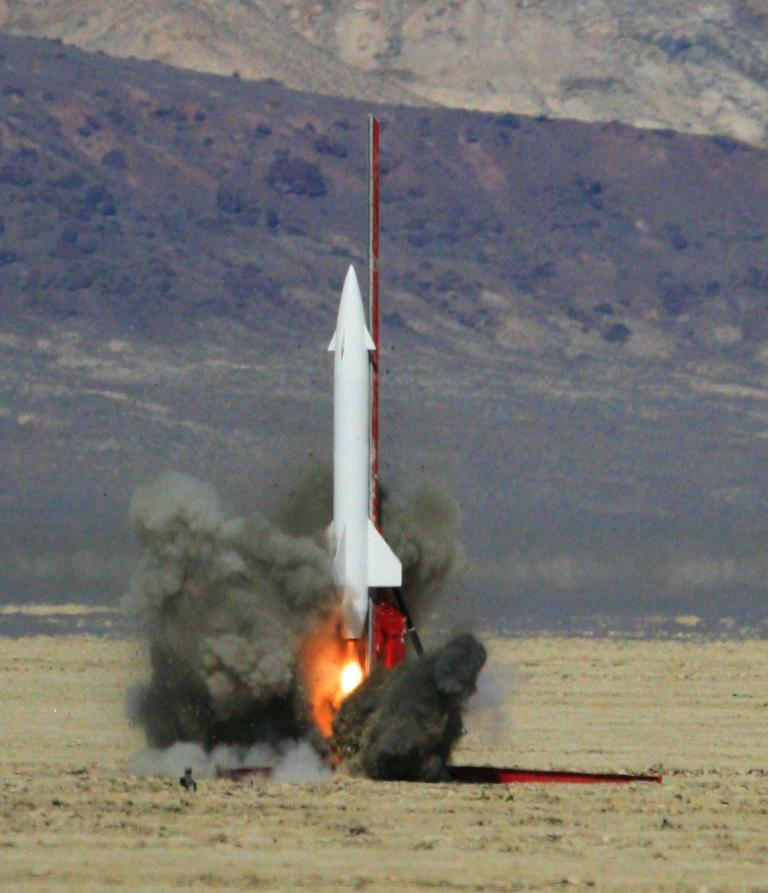What is the main subject of the image? There is a rocket in the center of the image. Where is the rocket located? The rocket is on the ground. What can be seen in the background of the image? There is a hill visible in the background of the image. Are there any cobwebs visible on the rocket in the image? There are no cobwebs visible on the rocket in the image. Can you see a dog playing near the rocket in the image? There is no dog present in the image; it only features a rocket on the ground and a hill in the background. 